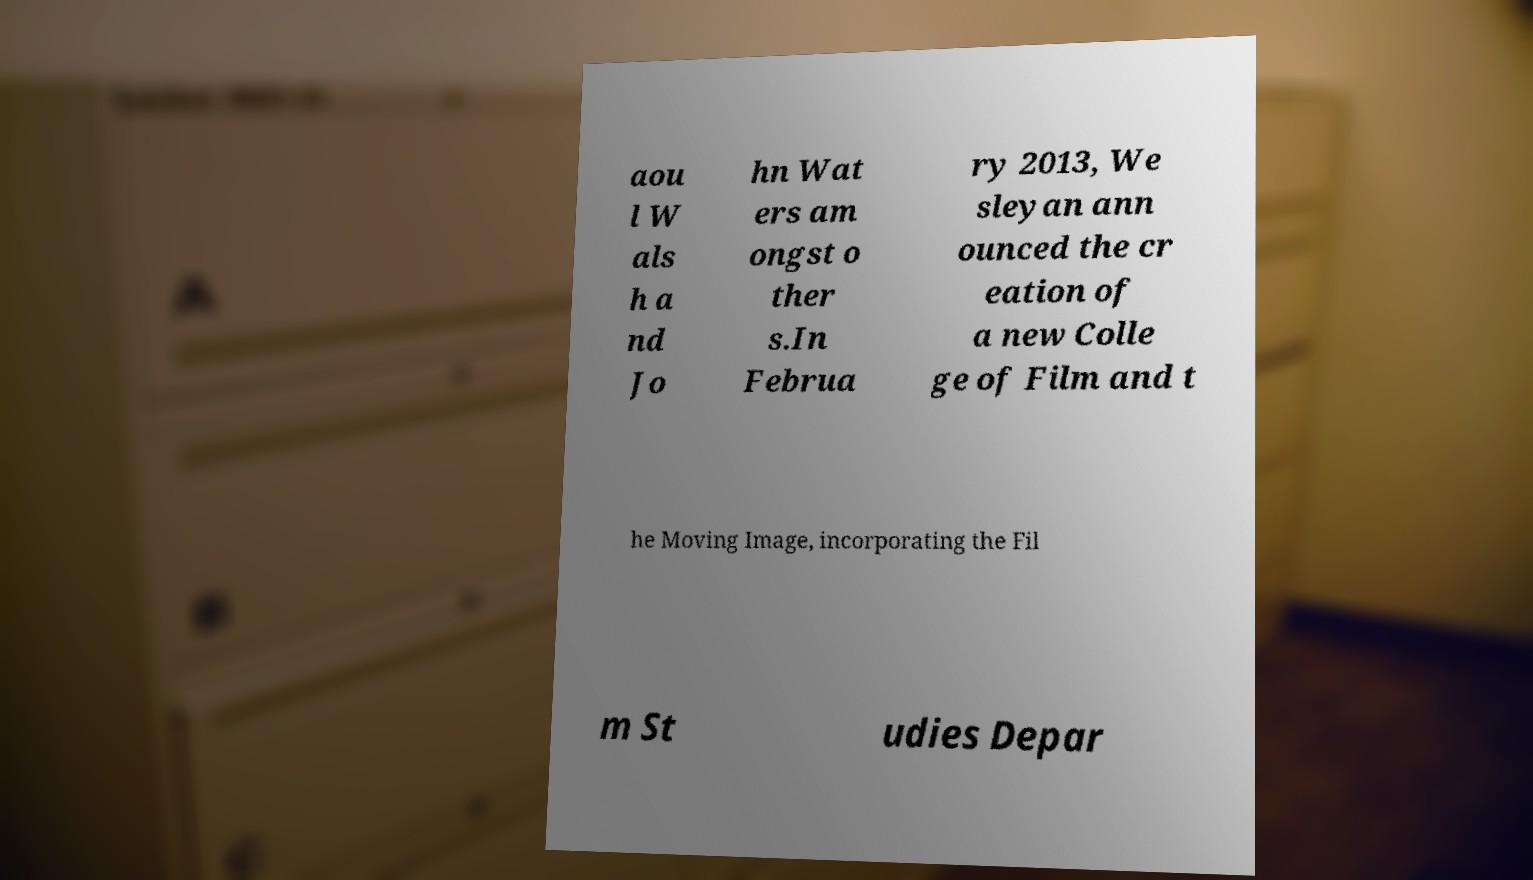There's text embedded in this image that I need extracted. Can you transcribe it verbatim? aou l W als h a nd Jo hn Wat ers am ongst o ther s.In Februa ry 2013, We sleyan ann ounced the cr eation of a new Colle ge of Film and t he Moving Image, incorporating the Fil m St udies Depar 